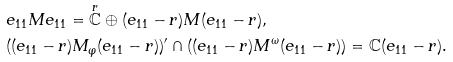<formula> <loc_0><loc_0><loc_500><loc_500>& e _ { 1 1 } M e _ { 1 1 } = \overset { r } { \mathbb { C } } \oplus ( e _ { 1 1 } - r ) M ( e _ { 1 1 } - r ) , \\ & ( ( e _ { 1 1 } - r ) M _ { \varphi } ( e _ { 1 1 } - r ) ) ^ { \prime } \cap ( ( e _ { 1 1 } - r ) M ^ { \omega } ( e _ { 1 1 } - r ) ) = \mathbb { C } ( e _ { 1 1 } - r ) .</formula> 